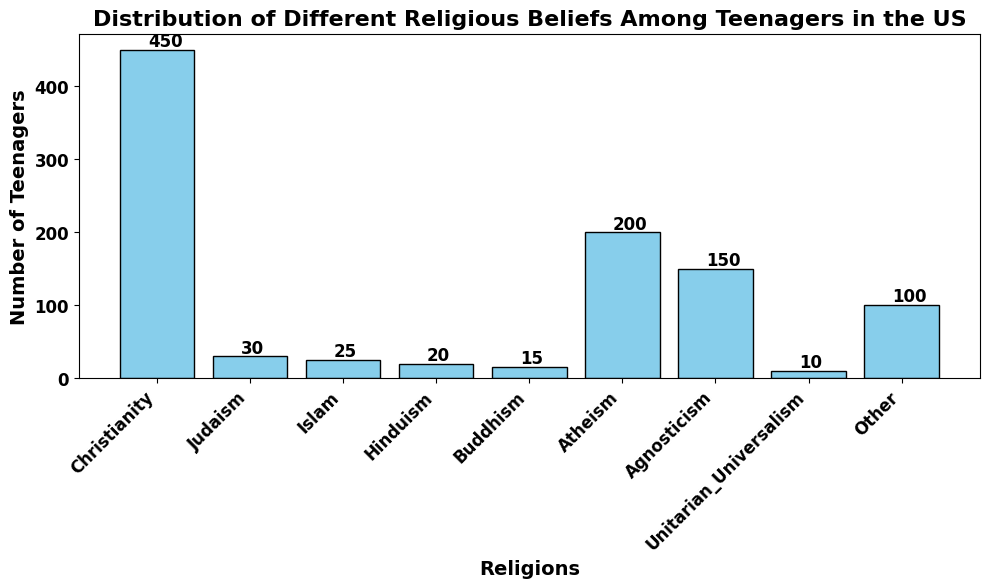What's the most common religious belief among teenagers in the US? The tallest bar represents Christianity, indicating it has the highest number of teenagers. The height of this bar is 450, the highest count.
Answer: Christianity How does the number of teenagers identifying as Atheist compare to those identifying as Agnostic? The bar for Atheism is 200 and the bar for Agnosticism is 150. Atheism has more teenagers than Agnosticism.
Answer: Atheism What is the least common religious belief among teenagers in the US? The shortest bar represents Unitarian Universalism, indicating it has the lowest number of teenagers. The height of this bar is 10, the lowest count.
Answer: Unitarian Universalism What's the total number of teenagers represented in the figure? Adding up the heights of all the bars: 450 + 30 + 25 + 20 + 15 + 200 + 150 + 10 + 100 = 1000.
Answer: 1000 What is the combined number of teenagers who identify with religions other than Christianity, Atheism, and Agnosticism? Summing up the heights of the bars excluding Christianity (450), Atheism (200), and Agnosticism (150): 30 + 25 + 20 + 15 + 10 + 100 = 200.
Answer: 200 Which religious belief has exactly half the number of teenagers compared to Christianity? Half of 450 (Christianity) is 225. No single bar is exactly 225, so no religion has exactly half the number of teenagers as Christianity.
Answer: None Rank the top three religious beliefs among teenagers and specify their counts. The highest bar is Christianity (450), followed by Atheism (200), and Agnosticism (150). These are ranked from tallest to shortest.
Answer: Christianity: 450, Atheism: 200, Agnosticism: 150 How many more teenagers identify as "Other" compared to those identifying as Unitarian Universalist? The number of teenagers identifying as "Other" is 100, and for Unitarian Universalism is 10. The difference is 100 - 10 = 90.
Answer: 90 What is the average number of teenagers across all religious beliefs? The total number of teenagers is 1000, and there are 9 categories. The average is 1000 / 9 ≈ 111.1.
Answer: 111.1 If you add the numbers of teenagers identifying as Islam and Judaism, is it greater than those identifying as Hinduism? Islam has 25 teenagers, and Judaism has 30. Summing these gives 25 + 30 = 55. Hinduism has 20 teenagers, so 55 > 20.
Answer: Yes 